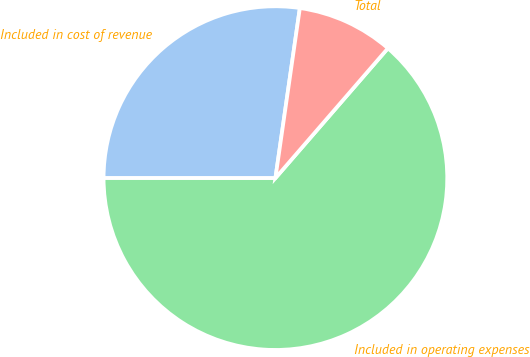<chart> <loc_0><loc_0><loc_500><loc_500><pie_chart><fcel>Included in cost of revenue<fcel>Included in operating expenses<fcel>Total<nl><fcel>27.27%<fcel>63.64%<fcel>9.09%<nl></chart> 